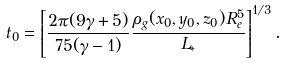Convert formula to latex. <formula><loc_0><loc_0><loc_500><loc_500>t _ { 0 } = \left [ \frac { 2 \pi ( 9 \gamma + 5 ) } { 7 5 ( \gamma - 1 ) } \frac { \rho _ { g } ( x _ { 0 } , y _ { 0 } , z _ { 0 } ) R _ { e } ^ { 5 } } { L _ { * } } \right ] ^ { 1 / 3 } .</formula> 